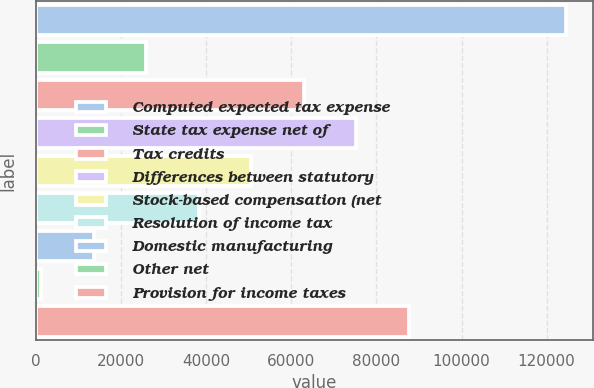<chart> <loc_0><loc_0><loc_500><loc_500><bar_chart><fcel>Computed expected tax expense<fcel>State tax expense net of<fcel>Tax credits<fcel>Differences between statutory<fcel>Stock-based compensation (net<fcel>Resolution of income tax<fcel>Domestic manufacturing<fcel>Other net<fcel>Provision for income taxes<nl><fcel>124649<fcel>25974.6<fcel>62977.5<fcel>75311.8<fcel>50643.2<fcel>38308.9<fcel>13640.3<fcel>1306<fcel>87646.1<nl></chart> 